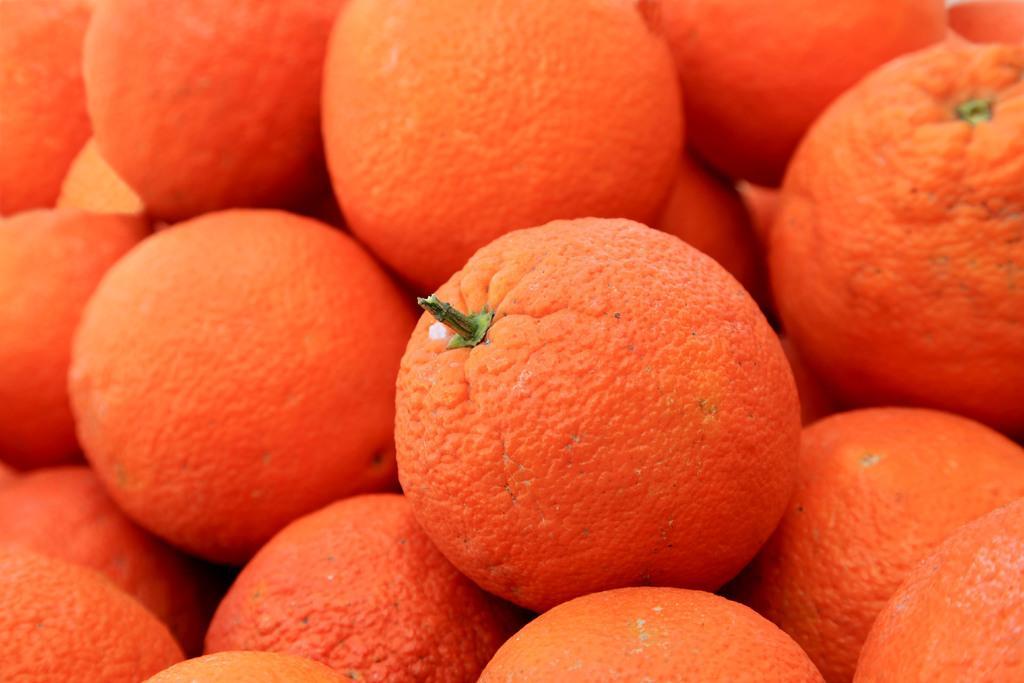Describe this image in one or two sentences. In this image we can see oranges. 